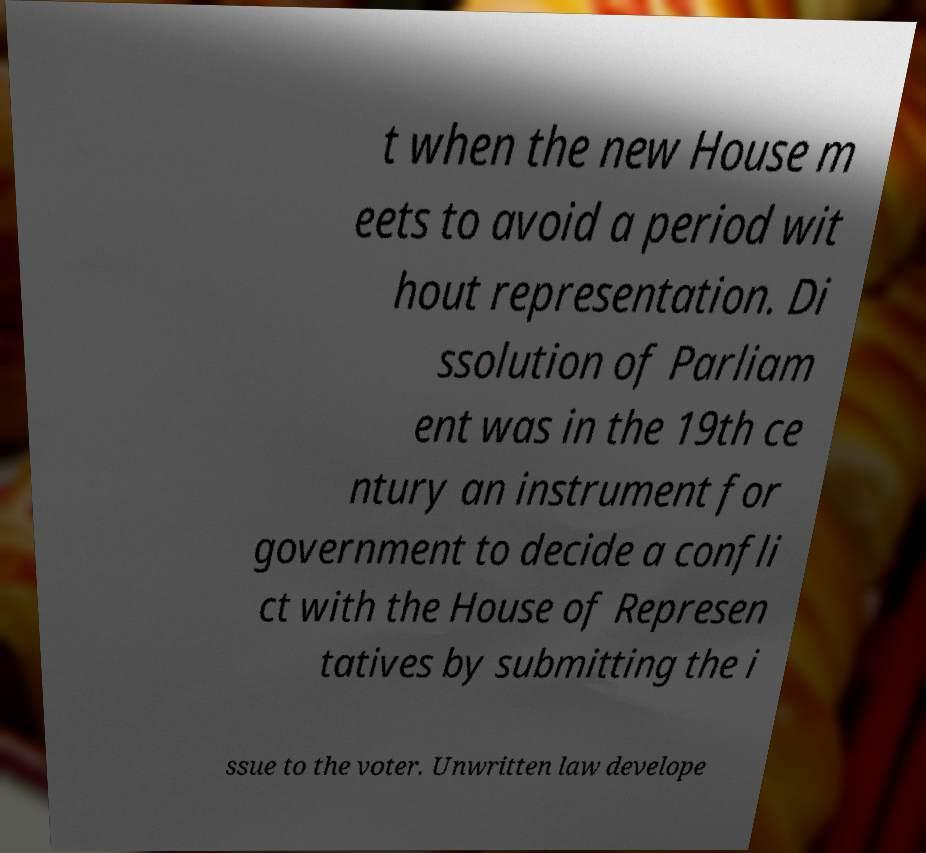For documentation purposes, I need the text within this image transcribed. Could you provide that? t when the new House m eets to avoid a period wit hout representation. Di ssolution of Parliam ent was in the 19th ce ntury an instrument for government to decide a confli ct with the House of Represen tatives by submitting the i ssue to the voter. Unwritten law develope 